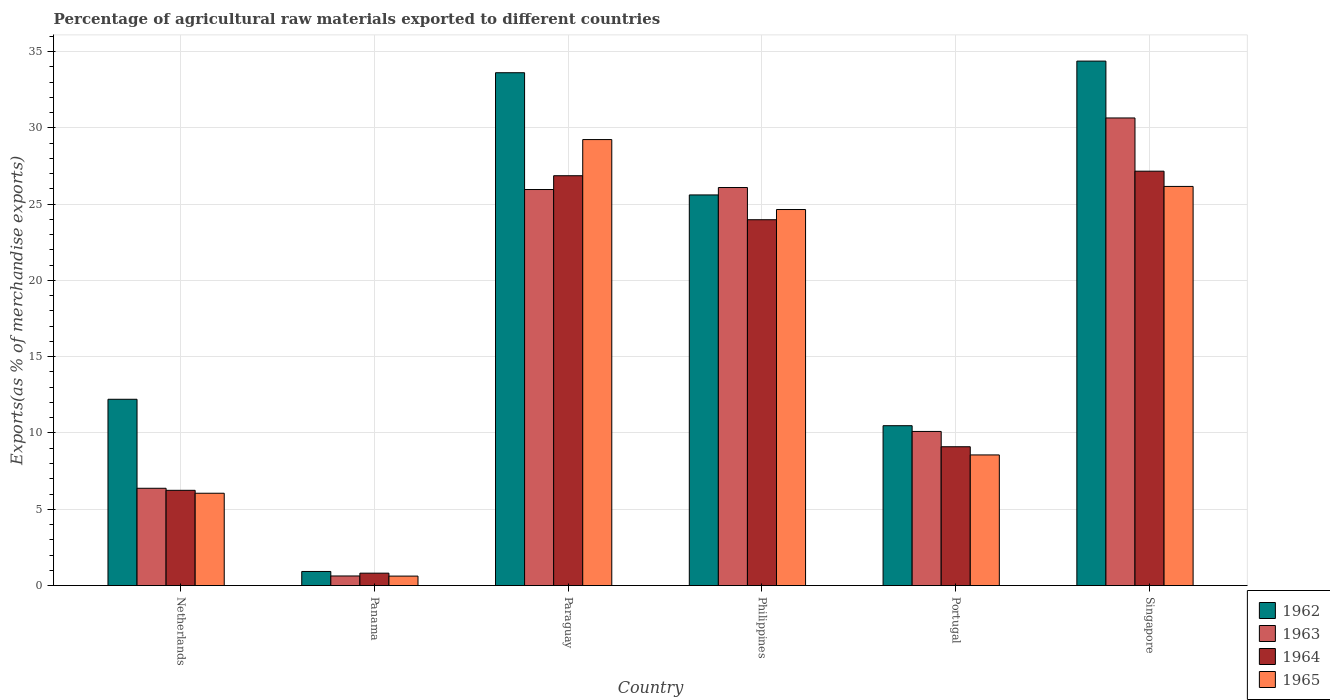How many different coloured bars are there?
Give a very brief answer. 4. How many groups of bars are there?
Your answer should be very brief. 6. How many bars are there on the 3rd tick from the left?
Keep it short and to the point. 4. How many bars are there on the 5th tick from the right?
Ensure brevity in your answer.  4. What is the label of the 3rd group of bars from the left?
Offer a very short reply. Paraguay. In how many cases, is the number of bars for a given country not equal to the number of legend labels?
Provide a short and direct response. 0. What is the percentage of exports to different countries in 1965 in Philippines?
Ensure brevity in your answer.  24.65. Across all countries, what is the maximum percentage of exports to different countries in 1964?
Make the answer very short. 27.16. Across all countries, what is the minimum percentage of exports to different countries in 1964?
Your answer should be compact. 0.81. In which country was the percentage of exports to different countries in 1964 maximum?
Give a very brief answer. Singapore. In which country was the percentage of exports to different countries in 1963 minimum?
Offer a very short reply. Panama. What is the total percentage of exports to different countries in 1964 in the graph?
Your answer should be very brief. 94.16. What is the difference between the percentage of exports to different countries in 1962 in Panama and that in Portugal?
Your response must be concise. -9.55. What is the difference between the percentage of exports to different countries in 1964 in Singapore and the percentage of exports to different countries in 1965 in Portugal?
Make the answer very short. 18.6. What is the average percentage of exports to different countries in 1965 per country?
Ensure brevity in your answer.  15.88. What is the difference between the percentage of exports to different countries of/in 1963 and percentage of exports to different countries of/in 1965 in Panama?
Your response must be concise. 0.01. What is the ratio of the percentage of exports to different countries in 1964 in Paraguay to that in Portugal?
Your answer should be very brief. 2.95. Is the difference between the percentage of exports to different countries in 1963 in Portugal and Singapore greater than the difference between the percentage of exports to different countries in 1965 in Portugal and Singapore?
Your response must be concise. No. What is the difference between the highest and the second highest percentage of exports to different countries in 1963?
Provide a short and direct response. -0.13. What is the difference between the highest and the lowest percentage of exports to different countries in 1963?
Provide a succinct answer. 30.02. What does the 1st bar from the left in Netherlands represents?
Offer a terse response. 1962. What does the 2nd bar from the right in Panama represents?
Your answer should be very brief. 1964. Is it the case that in every country, the sum of the percentage of exports to different countries in 1963 and percentage of exports to different countries in 1964 is greater than the percentage of exports to different countries in 1962?
Your answer should be compact. Yes. How many bars are there?
Provide a short and direct response. 24. How many countries are there in the graph?
Offer a terse response. 6. Are the values on the major ticks of Y-axis written in scientific E-notation?
Ensure brevity in your answer.  No. Where does the legend appear in the graph?
Provide a short and direct response. Bottom right. What is the title of the graph?
Ensure brevity in your answer.  Percentage of agricultural raw materials exported to different countries. Does "1986" appear as one of the legend labels in the graph?
Offer a terse response. No. What is the label or title of the Y-axis?
Offer a very short reply. Exports(as % of merchandise exports). What is the Exports(as % of merchandise exports) in 1962 in Netherlands?
Provide a succinct answer. 12.21. What is the Exports(as % of merchandise exports) of 1963 in Netherlands?
Offer a very short reply. 6.38. What is the Exports(as % of merchandise exports) in 1964 in Netherlands?
Offer a very short reply. 6.24. What is the Exports(as % of merchandise exports) of 1965 in Netherlands?
Your answer should be compact. 6.05. What is the Exports(as % of merchandise exports) of 1962 in Panama?
Provide a short and direct response. 0.92. What is the Exports(as % of merchandise exports) of 1963 in Panama?
Ensure brevity in your answer.  0.63. What is the Exports(as % of merchandise exports) in 1964 in Panama?
Your answer should be compact. 0.81. What is the Exports(as % of merchandise exports) of 1965 in Panama?
Give a very brief answer. 0.62. What is the Exports(as % of merchandise exports) in 1962 in Paraguay?
Your response must be concise. 33.61. What is the Exports(as % of merchandise exports) of 1963 in Paraguay?
Ensure brevity in your answer.  25.96. What is the Exports(as % of merchandise exports) of 1964 in Paraguay?
Your answer should be very brief. 26.86. What is the Exports(as % of merchandise exports) in 1965 in Paraguay?
Give a very brief answer. 29.23. What is the Exports(as % of merchandise exports) in 1962 in Philippines?
Give a very brief answer. 25.6. What is the Exports(as % of merchandise exports) of 1963 in Philippines?
Offer a terse response. 26.09. What is the Exports(as % of merchandise exports) of 1964 in Philippines?
Ensure brevity in your answer.  23.98. What is the Exports(as % of merchandise exports) in 1965 in Philippines?
Your response must be concise. 24.65. What is the Exports(as % of merchandise exports) of 1962 in Portugal?
Your answer should be very brief. 10.48. What is the Exports(as % of merchandise exports) in 1963 in Portugal?
Your response must be concise. 10.1. What is the Exports(as % of merchandise exports) of 1964 in Portugal?
Provide a succinct answer. 9.1. What is the Exports(as % of merchandise exports) of 1965 in Portugal?
Ensure brevity in your answer.  8.56. What is the Exports(as % of merchandise exports) of 1962 in Singapore?
Ensure brevity in your answer.  34.38. What is the Exports(as % of merchandise exports) of 1963 in Singapore?
Keep it short and to the point. 30.65. What is the Exports(as % of merchandise exports) in 1964 in Singapore?
Keep it short and to the point. 27.16. What is the Exports(as % of merchandise exports) in 1965 in Singapore?
Make the answer very short. 26.16. Across all countries, what is the maximum Exports(as % of merchandise exports) of 1962?
Make the answer very short. 34.38. Across all countries, what is the maximum Exports(as % of merchandise exports) in 1963?
Your answer should be compact. 30.65. Across all countries, what is the maximum Exports(as % of merchandise exports) of 1964?
Make the answer very short. 27.16. Across all countries, what is the maximum Exports(as % of merchandise exports) of 1965?
Keep it short and to the point. 29.23. Across all countries, what is the minimum Exports(as % of merchandise exports) in 1962?
Keep it short and to the point. 0.92. Across all countries, what is the minimum Exports(as % of merchandise exports) in 1963?
Give a very brief answer. 0.63. Across all countries, what is the minimum Exports(as % of merchandise exports) of 1964?
Your response must be concise. 0.81. Across all countries, what is the minimum Exports(as % of merchandise exports) in 1965?
Your answer should be compact. 0.62. What is the total Exports(as % of merchandise exports) of 1962 in the graph?
Provide a succinct answer. 117.21. What is the total Exports(as % of merchandise exports) in 1963 in the graph?
Your answer should be very brief. 99.8. What is the total Exports(as % of merchandise exports) in 1964 in the graph?
Give a very brief answer. 94.16. What is the total Exports(as % of merchandise exports) of 1965 in the graph?
Your response must be concise. 95.28. What is the difference between the Exports(as % of merchandise exports) of 1962 in Netherlands and that in Panama?
Ensure brevity in your answer.  11.29. What is the difference between the Exports(as % of merchandise exports) in 1963 in Netherlands and that in Panama?
Give a very brief answer. 5.75. What is the difference between the Exports(as % of merchandise exports) in 1964 in Netherlands and that in Panama?
Your answer should be very brief. 5.43. What is the difference between the Exports(as % of merchandise exports) in 1965 in Netherlands and that in Panama?
Give a very brief answer. 5.43. What is the difference between the Exports(as % of merchandise exports) of 1962 in Netherlands and that in Paraguay?
Your answer should be compact. -21.4. What is the difference between the Exports(as % of merchandise exports) of 1963 in Netherlands and that in Paraguay?
Make the answer very short. -19.58. What is the difference between the Exports(as % of merchandise exports) of 1964 in Netherlands and that in Paraguay?
Provide a succinct answer. -20.62. What is the difference between the Exports(as % of merchandise exports) in 1965 in Netherlands and that in Paraguay?
Your answer should be compact. -23.18. What is the difference between the Exports(as % of merchandise exports) of 1962 in Netherlands and that in Philippines?
Offer a terse response. -13.39. What is the difference between the Exports(as % of merchandise exports) in 1963 in Netherlands and that in Philippines?
Your answer should be very brief. -19.71. What is the difference between the Exports(as % of merchandise exports) of 1964 in Netherlands and that in Philippines?
Keep it short and to the point. -17.74. What is the difference between the Exports(as % of merchandise exports) in 1965 in Netherlands and that in Philippines?
Ensure brevity in your answer.  -18.6. What is the difference between the Exports(as % of merchandise exports) in 1962 in Netherlands and that in Portugal?
Keep it short and to the point. 1.73. What is the difference between the Exports(as % of merchandise exports) of 1963 in Netherlands and that in Portugal?
Give a very brief answer. -3.73. What is the difference between the Exports(as % of merchandise exports) of 1964 in Netherlands and that in Portugal?
Provide a short and direct response. -2.86. What is the difference between the Exports(as % of merchandise exports) in 1965 in Netherlands and that in Portugal?
Your answer should be compact. -2.51. What is the difference between the Exports(as % of merchandise exports) in 1962 in Netherlands and that in Singapore?
Make the answer very short. -22.17. What is the difference between the Exports(as % of merchandise exports) of 1963 in Netherlands and that in Singapore?
Provide a short and direct response. -24.27. What is the difference between the Exports(as % of merchandise exports) of 1964 in Netherlands and that in Singapore?
Your answer should be compact. -20.92. What is the difference between the Exports(as % of merchandise exports) of 1965 in Netherlands and that in Singapore?
Make the answer very short. -20.11. What is the difference between the Exports(as % of merchandise exports) of 1962 in Panama and that in Paraguay?
Your answer should be compact. -32.69. What is the difference between the Exports(as % of merchandise exports) of 1963 in Panama and that in Paraguay?
Your answer should be very brief. -25.33. What is the difference between the Exports(as % of merchandise exports) in 1964 in Panama and that in Paraguay?
Make the answer very short. -26.05. What is the difference between the Exports(as % of merchandise exports) of 1965 in Panama and that in Paraguay?
Ensure brevity in your answer.  -28.61. What is the difference between the Exports(as % of merchandise exports) in 1962 in Panama and that in Philippines?
Your answer should be very brief. -24.68. What is the difference between the Exports(as % of merchandise exports) in 1963 in Panama and that in Philippines?
Offer a terse response. -25.46. What is the difference between the Exports(as % of merchandise exports) of 1964 in Panama and that in Philippines?
Ensure brevity in your answer.  -23.17. What is the difference between the Exports(as % of merchandise exports) of 1965 in Panama and that in Philippines?
Keep it short and to the point. -24.03. What is the difference between the Exports(as % of merchandise exports) of 1962 in Panama and that in Portugal?
Provide a succinct answer. -9.55. What is the difference between the Exports(as % of merchandise exports) in 1963 in Panama and that in Portugal?
Your answer should be very brief. -9.47. What is the difference between the Exports(as % of merchandise exports) of 1964 in Panama and that in Portugal?
Keep it short and to the point. -8.29. What is the difference between the Exports(as % of merchandise exports) in 1965 in Panama and that in Portugal?
Your answer should be compact. -7.94. What is the difference between the Exports(as % of merchandise exports) of 1962 in Panama and that in Singapore?
Offer a very short reply. -33.45. What is the difference between the Exports(as % of merchandise exports) of 1963 in Panama and that in Singapore?
Give a very brief answer. -30.02. What is the difference between the Exports(as % of merchandise exports) of 1964 in Panama and that in Singapore?
Provide a short and direct response. -26.35. What is the difference between the Exports(as % of merchandise exports) in 1965 in Panama and that in Singapore?
Keep it short and to the point. -25.54. What is the difference between the Exports(as % of merchandise exports) of 1962 in Paraguay and that in Philippines?
Keep it short and to the point. 8.01. What is the difference between the Exports(as % of merchandise exports) in 1963 in Paraguay and that in Philippines?
Keep it short and to the point. -0.13. What is the difference between the Exports(as % of merchandise exports) of 1964 in Paraguay and that in Philippines?
Your answer should be very brief. 2.88. What is the difference between the Exports(as % of merchandise exports) of 1965 in Paraguay and that in Philippines?
Provide a succinct answer. 4.59. What is the difference between the Exports(as % of merchandise exports) of 1962 in Paraguay and that in Portugal?
Your answer should be very brief. 23.14. What is the difference between the Exports(as % of merchandise exports) of 1963 in Paraguay and that in Portugal?
Give a very brief answer. 15.86. What is the difference between the Exports(as % of merchandise exports) in 1964 in Paraguay and that in Portugal?
Ensure brevity in your answer.  17.76. What is the difference between the Exports(as % of merchandise exports) of 1965 in Paraguay and that in Portugal?
Offer a very short reply. 20.67. What is the difference between the Exports(as % of merchandise exports) of 1962 in Paraguay and that in Singapore?
Your response must be concise. -0.76. What is the difference between the Exports(as % of merchandise exports) of 1963 in Paraguay and that in Singapore?
Your answer should be very brief. -4.69. What is the difference between the Exports(as % of merchandise exports) in 1964 in Paraguay and that in Singapore?
Your answer should be compact. -0.3. What is the difference between the Exports(as % of merchandise exports) of 1965 in Paraguay and that in Singapore?
Make the answer very short. 3.07. What is the difference between the Exports(as % of merchandise exports) of 1962 in Philippines and that in Portugal?
Your response must be concise. 15.13. What is the difference between the Exports(as % of merchandise exports) of 1963 in Philippines and that in Portugal?
Offer a terse response. 15.99. What is the difference between the Exports(as % of merchandise exports) of 1964 in Philippines and that in Portugal?
Offer a very short reply. 14.88. What is the difference between the Exports(as % of merchandise exports) in 1965 in Philippines and that in Portugal?
Offer a terse response. 16.08. What is the difference between the Exports(as % of merchandise exports) in 1962 in Philippines and that in Singapore?
Your response must be concise. -8.77. What is the difference between the Exports(as % of merchandise exports) in 1963 in Philippines and that in Singapore?
Ensure brevity in your answer.  -4.56. What is the difference between the Exports(as % of merchandise exports) in 1964 in Philippines and that in Singapore?
Your answer should be very brief. -3.18. What is the difference between the Exports(as % of merchandise exports) in 1965 in Philippines and that in Singapore?
Provide a short and direct response. -1.51. What is the difference between the Exports(as % of merchandise exports) of 1962 in Portugal and that in Singapore?
Offer a terse response. -23.9. What is the difference between the Exports(as % of merchandise exports) of 1963 in Portugal and that in Singapore?
Offer a very short reply. -20.55. What is the difference between the Exports(as % of merchandise exports) of 1964 in Portugal and that in Singapore?
Your answer should be very brief. -18.06. What is the difference between the Exports(as % of merchandise exports) of 1965 in Portugal and that in Singapore?
Give a very brief answer. -17.6. What is the difference between the Exports(as % of merchandise exports) of 1962 in Netherlands and the Exports(as % of merchandise exports) of 1963 in Panama?
Give a very brief answer. 11.58. What is the difference between the Exports(as % of merchandise exports) in 1962 in Netherlands and the Exports(as % of merchandise exports) in 1964 in Panama?
Give a very brief answer. 11.4. What is the difference between the Exports(as % of merchandise exports) in 1962 in Netherlands and the Exports(as % of merchandise exports) in 1965 in Panama?
Give a very brief answer. 11.59. What is the difference between the Exports(as % of merchandise exports) in 1963 in Netherlands and the Exports(as % of merchandise exports) in 1964 in Panama?
Offer a very short reply. 5.56. What is the difference between the Exports(as % of merchandise exports) in 1963 in Netherlands and the Exports(as % of merchandise exports) in 1965 in Panama?
Keep it short and to the point. 5.76. What is the difference between the Exports(as % of merchandise exports) in 1964 in Netherlands and the Exports(as % of merchandise exports) in 1965 in Panama?
Give a very brief answer. 5.62. What is the difference between the Exports(as % of merchandise exports) of 1962 in Netherlands and the Exports(as % of merchandise exports) of 1963 in Paraguay?
Your answer should be compact. -13.75. What is the difference between the Exports(as % of merchandise exports) of 1962 in Netherlands and the Exports(as % of merchandise exports) of 1964 in Paraguay?
Your answer should be very brief. -14.65. What is the difference between the Exports(as % of merchandise exports) of 1962 in Netherlands and the Exports(as % of merchandise exports) of 1965 in Paraguay?
Your response must be concise. -17.02. What is the difference between the Exports(as % of merchandise exports) of 1963 in Netherlands and the Exports(as % of merchandise exports) of 1964 in Paraguay?
Your response must be concise. -20.49. What is the difference between the Exports(as % of merchandise exports) of 1963 in Netherlands and the Exports(as % of merchandise exports) of 1965 in Paraguay?
Offer a very short reply. -22.86. What is the difference between the Exports(as % of merchandise exports) of 1964 in Netherlands and the Exports(as % of merchandise exports) of 1965 in Paraguay?
Make the answer very short. -22.99. What is the difference between the Exports(as % of merchandise exports) of 1962 in Netherlands and the Exports(as % of merchandise exports) of 1963 in Philippines?
Make the answer very short. -13.88. What is the difference between the Exports(as % of merchandise exports) in 1962 in Netherlands and the Exports(as % of merchandise exports) in 1964 in Philippines?
Give a very brief answer. -11.77. What is the difference between the Exports(as % of merchandise exports) in 1962 in Netherlands and the Exports(as % of merchandise exports) in 1965 in Philippines?
Give a very brief answer. -12.44. What is the difference between the Exports(as % of merchandise exports) of 1963 in Netherlands and the Exports(as % of merchandise exports) of 1964 in Philippines?
Keep it short and to the point. -17.6. What is the difference between the Exports(as % of merchandise exports) in 1963 in Netherlands and the Exports(as % of merchandise exports) in 1965 in Philippines?
Your answer should be very brief. -18.27. What is the difference between the Exports(as % of merchandise exports) of 1964 in Netherlands and the Exports(as % of merchandise exports) of 1965 in Philippines?
Ensure brevity in your answer.  -18.4. What is the difference between the Exports(as % of merchandise exports) in 1962 in Netherlands and the Exports(as % of merchandise exports) in 1963 in Portugal?
Give a very brief answer. 2.11. What is the difference between the Exports(as % of merchandise exports) in 1962 in Netherlands and the Exports(as % of merchandise exports) in 1964 in Portugal?
Your answer should be very brief. 3.11. What is the difference between the Exports(as % of merchandise exports) in 1962 in Netherlands and the Exports(as % of merchandise exports) in 1965 in Portugal?
Ensure brevity in your answer.  3.65. What is the difference between the Exports(as % of merchandise exports) in 1963 in Netherlands and the Exports(as % of merchandise exports) in 1964 in Portugal?
Make the answer very short. -2.72. What is the difference between the Exports(as % of merchandise exports) of 1963 in Netherlands and the Exports(as % of merchandise exports) of 1965 in Portugal?
Your answer should be very brief. -2.19. What is the difference between the Exports(as % of merchandise exports) in 1964 in Netherlands and the Exports(as % of merchandise exports) in 1965 in Portugal?
Give a very brief answer. -2.32. What is the difference between the Exports(as % of merchandise exports) of 1962 in Netherlands and the Exports(as % of merchandise exports) of 1963 in Singapore?
Keep it short and to the point. -18.44. What is the difference between the Exports(as % of merchandise exports) of 1962 in Netherlands and the Exports(as % of merchandise exports) of 1964 in Singapore?
Provide a short and direct response. -14.95. What is the difference between the Exports(as % of merchandise exports) of 1962 in Netherlands and the Exports(as % of merchandise exports) of 1965 in Singapore?
Provide a succinct answer. -13.95. What is the difference between the Exports(as % of merchandise exports) in 1963 in Netherlands and the Exports(as % of merchandise exports) in 1964 in Singapore?
Offer a terse response. -20.78. What is the difference between the Exports(as % of merchandise exports) in 1963 in Netherlands and the Exports(as % of merchandise exports) in 1965 in Singapore?
Ensure brevity in your answer.  -19.78. What is the difference between the Exports(as % of merchandise exports) of 1964 in Netherlands and the Exports(as % of merchandise exports) of 1965 in Singapore?
Your answer should be very brief. -19.92. What is the difference between the Exports(as % of merchandise exports) in 1962 in Panama and the Exports(as % of merchandise exports) in 1963 in Paraguay?
Provide a succinct answer. -25.03. What is the difference between the Exports(as % of merchandise exports) in 1962 in Panama and the Exports(as % of merchandise exports) in 1964 in Paraguay?
Make the answer very short. -25.94. What is the difference between the Exports(as % of merchandise exports) of 1962 in Panama and the Exports(as % of merchandise exports) of 1965 in Paraguay?
Your answer should be compact. -28.31. What is the difference between the Exports(as % of merchandise exports) in 1963 in Panama and the Exports(as % of merchandise exports) in 1964 in Paraguay?
Your answer should be compact. -26.23. What is the difference between the Exports(as % of merchandise exports) of 1963 in Panama and the Exports(as % of merchandise exports) of 1965 in Paraguay?
Ensure brevity in your answer.  -28.6. What is the difference between the Exports(as % of merchandise exports) of 1964 in Panama and the Exports(as % of merchandise exports) of 1965 in Paraguay?
Offer a very short reply. -28.42. What is the difference between the Exports(as % of merchandise exports) of 1962 in Panama and the Exports(as % of merchandise exports) of 1963 in Philippines?
Keep it short and to the point. -25.16. What is the difference between the Exports(as % of merchandise exports) in 1962 in Panama and the Exports(as % of merchandise exports) in 1964 in Philippines?
Offer a very short reply. -23.05. What is the difference between the Exports(as % of merchandise exports) of 1962 in Panama and the Exports(as % of merchandise exports) of 1965 in Philippines?
Ensure brevity in your answer.  -23.72. What is the difference between the Exports(as % of merchandise exports) of 1963 in Panama and the Exports(as % of merchandise exports) of 1964 in Philippines?
Keep it short and to the point. -23.35. What is the difference between the Exports(as % of merchandise exports) in 1963 in Panama and the Exports(as % of merchandise exports) in 1965 in Philippines?
Provide a short and direct response. -24.02. What is the difference between the Exports(as % of merchandise exports) in 1964 in Panama and the Exports(as % of merchandise exports) in 1965 in Philippines?
Offer a very short reply. -23.84. What is the difference between the Exports(as % of merchandise exports) of 1962 in Panama and the Exports(as % of merchandise exports) of 1963 in Portugal?
Make the answer very short. -9.18. What is the difference between the Exports(as % of merchandise exports) in 1962 in Panama and the Exports(as % of merchandise exports) in 1964 in Portugal?
Provide a succinct answer. -8.17. What is the difference between the Exports(as % of merchandise exports) of 1962 in Panama and the Exports(as % of merchandise exports) of 1965 in Portugal?
Your response must be concise. -7.64. What is the difference between the Exports(as % of merchandise exports) of 1963 in Panama and the Exports(as % of merchandise exports) of 1964 in Portugal?
Your response must be concise. -8.47. What is the difference between the Exports(as % of merchandise exports) of 1963 in Panama and the Exports(as % of merchandise exports) of 1965 in Portugal?
Offer a terse response. -7.93. What is the difference between the Exports(as % of merchandise exports) of 1964 in Panama and the Exports(as % of merchandise exports) of 1965 in Portugal?
Offer a terse response. -7.75. What is the difference between the Exports(as % of merchandise exports) in 1962 in Panama and the Exports(as % of merchandise exports) in 1963 in Singapore?
Provide a succinct answer. -29.72. What is the difference between the Exports(as % of merchandise exports) of 1962 in Panama and the Exports(as % of merchandise exports) of 1964 in Singapore?
Give a very brief answer. -26.24. What is the difference between the Exports(as % of merchandise exports) of 1962 in Panama and the Exports(as % of merchandise exports) of 1965 in Singapore?
Offer a terse response. -25.24. What is the difference between the Exports(as % of merchandise exports) of 1963 in Panama and the Exports(as % of merchandise exports) of 1964 in Singapore?
Give a very brief answer. -26.53. What is the difference between the Exports(as % of merchandise exports) in 1963 in Panama and the Exports(as % of merchandise exports) in 1965 in Singapore?
Offer a very short reply. -25.53. What is the difference between the Exports(as % of merchandise exports) of 1964 in Panama and the Exports(as % of merchandise exports) of 1965 in Singapore?
Your response must be concise. -25.35. What is the difference between the Exports(as % of merchandise exports) in 1962 in Paraguay and the Exports(as % of merchandise exports) in 1963 in Philippines?
Your answer should be very brief. 7.53. What is the difference between the Exports(as % of merchandise exports) of 1962 in Paraguay and the Exports(as % of merchandise exports) of 1964 in Philippines?
Provide a succinct answer. 9.64. What is the difference between the Exports(as % of merchandise exports) of 1962 in Paraguay and the Exports(as % of merchandise exports) of 1965 in Philippines?
Offer a very short reply. 8.97. What is the difference between the Exports(as % of merchandise exports) in 1963 in Paraguay and the Exports(as % of merchandise exports) in 1964 in Philippines?
Offer a terse response. 1.98. What is the difference between the Exports(as % of merchandise exports) of 1963 in Paraguay and the Exports(as % of merchandise exports) of 1965 in Philippines?
Offer a very short reply. 1.31. What is the difference between the Exports(as % of merchandise exports) of 1964 in Paraguay and the Exports(as % of merchandise exports) of 1965 in Philippines?
Ensure brevity in your answer.  2.22. What is the difference between the Exports(as % of merchandise exports) in 1962 in Paraguay and the Exports(as % of merchandise exports) in 1963 in Portugal?
Offer a terse response. 23.51. What is the difference between the Exports(as % of merchandise exports) in 1962 in Paraguay and the Exports(as % of merchandise exports) in 1964 in Portugal?
Provide a succinct answer. 24.52. What is the difference between the Exports(as % of merchandise exports) in 1962 in Paraguay and the Exports(as % of merchandise exports) in 1965 in Portugal?
Offer a terse response. 25.05. What is the difference between the Exports(as % of merchandise exports) of 1963 in Paraguay and the Exports(as % of merchandise exports) of 1964 in Portugal?
Your answer should be compact. 16.86. What is the difference between the Exports(as % of merchandise exports) in 1963 in Paraguay and the Exports(as % of merchandise exports) in 1965 in Portugal?
Offer a terse response. 17.4. What is the difference between the Exports(as % of merchandise exports) in 1964 in Paraguay and the Exports(as % of merchandise exports) in 1965 in Portugal?
Offer a very short reply. 18.3. What is the difference between the Exports(as % of merchandise exports) in 1962 in Paraguay and the Exports(as % of merchandise exports) in 1963 in Singapore?
Provide a succinct answer. 2.97. What is the difference between the Exports(as % of merchandise exports) of 1962 in Paraguay and the Exports(as % of merchandise exports) of 1964 in Singapore?
Keep it short and to the point. 6.45. What is the difference between the Exports(as % of merchandise exports) in 1962 in Paraguay and the Exports(as % of merchandise exports) in 1965 in Singapore?
Provide a short and direct response. 7.45. What is the difference between the Exports(as % of merchandise exports) of 1963 in Paraguay and the Exports(as % of merchandise exports) of 1964 in Singapore?
Make the answer very short. -1.2. What is the difference between the Exports(as % of merchandise exports) in 1963 in Paraguay and the Exports(as % of merchandise exports) in 1965 in Singapore?
Keep it short and to the point. -0.2. What is the difference between the Exports(as % of merchandise exports) of 1964 in Paraguay and the Exports(as % of merchandise exports) of 1965 in Singapore?
Provide a short and direct response. 0.7. What is the difference between the Exports(as % of merchandise exports) in 1962 in Philippines and the Exports(as % of merchandise exports) in 1963 in Portugal?
Your response must be concise. 15.5. What is the difference between the Exports(as % of merchandise exports) of 1962 in Philippines and the Exports(as % of merchandise exports) of 1964 in Portugal?
Make the answer very short. 16.5. What is the difference between the Exports(as % of merchandise exports) of 1962 in Philippines and the Exports(as % of merchandise exports) of 1965 in Portugal?
Ensure brevity in your answer.  17.04. What is the difference between the Exports(as % of merchandise exports) in 1963 in Philippines and the Exports(as % of merchandise exports) in 1964 in Portugal?
Provide a succinct answer. 16.99. What is the difference between the Exports(as % of merchandise exports) of 1963 in Philippines and the Exports(as % of merchandise exports) of 1965 in Portugal?
Offer a very short reply. 17.53. What is the difference between the Exports(as % of merchandise exports) in 1964 in Philippines and the Exports(as % of merchandise exports) in 1965 in Portugal?
Your answer should be compact. 15.42. What is the difference between the Exports(as % of merchandise exports) of 1962 in Philippines and the Exports(as % of merchandise exports) of 1963 in Singapore?
Offer a very short reply. -5.04. What is the difference between the Exports(as % of merchandise exports) of 1962 in Philippines and the Exports(as % of merchandise exports) of 1964 in Singapore?
Your answer should be compact. -1.56. What is the difference between the Exports(as % of merchandise exports) of 1962 in Philippines and the Exports(as % of merchandise exports) of 1965 in Singapore?
Your response must be concise. -0.56. What is the difference between the Exports(as % of merchandise exports) in 1963 in Philippines and the Exports(as % of merchandise exports) in 1964 in Singapore?
Give a very brief answer. -1.07. What is the difference between the Exports(as % of merchandise exports) of 1963 in Philippines and the Exports(as % of merchandise exports) of 1965 in Singapore?
Ensure brevity in your answer.  -0.07. What is the difference between the Exports(as % of merchandise exports) in 1964 in Philippines and the Exports(as % of merchandise exports) in 1965 in Singapore?
Your answer should be very brief. -2.18. What is the difference between the Exports(as % of merchandise exports) of 1962 in Portugal and the Exports(as % of merchandise exports) of 1963 in Singapore?
Offer a terse response. -20.17. What is the difference between the Exports(as % of merchandise exports) in 1962 in Portugal and the Exports(as % of merchandise exports) in 1964 in Singapore?
Keep it short and to the point. -16.68. What is the difference between the Exports(as % of merchandise exports) in 1962 in Portugal and the Exports(as % of merchandise exports) in 1965 in Singapore?
Keep it short and to the point. -15.68. What is the difference between the Exports(as % of merchandise exports) of 1963 in Portugal and the Exports(as % of merchandise exports) of 1964 in Singapore?
Offer a very short reply. -17.06. What is the difference between the Exports(as % of merchandise exports) in 1963 in Portugal and the Exports(as % of merchandise exports) in 1965 in Singapore?
Offer a terse response. -16.06. What is the difference between the Exports(as % of merchandise exports) of 1964 in Portugal and the Exports(as % of merchandise exports) of 1965 in Singapore?
Offer a terse response. -17.06. What is the average Exports(as % of merchandise exports) of 1962 per country?
Provide a succinct answer. 19.53. What is the average Exports(as % of merchandise exports) in 1963 per country?
Provide a succinct answer. 16.63. What is the average Exports(as % of merchandise exports) of 1964 per country?
Offer a terse response. 15.69. What is the average Exports(as % of merchandise exports) of 1965 per country?
Your answer should be very brief. 15.88. What is the difference between the Exports(as % of merchandise exports) in 1962 and Exports(as % of merchandise exports) in 1963 in Netherlands?
Offer a very short reply. 5.83. What is the difference between the Exports(as % of merchandise exports) in 1962 and Exports(as % of merchandise exports) in 1964 in Netherlands?
Your response must be concise. 5.97. What is the difference between the Exports(as % of merchandise exports) in 1962 and Exports(as % of merchandise exports) in 1965 in Netherlands?
Provide a succinct answer. 6.16. What is the difference between the Exports(as % of merchandise exports) in 1963 and Exports(as % of merchandise exports) in 1964 in Netherlands?
Offer a very short reply. 0.13. What is the difference between the Exports(as % of merchandise exports) of 1963 and Exports(as % of merchandise exports) of 1965 in Netherlands?
Your answer should be compact. 0.32. What is the difference between the Exports(as % of merchandise exports) of 1964 and Exports(as % of merchandise exports) of 1965 in Netherlands?
Offer a terse response. 0.19. What is the difference between the Exports(as % of merchandise exports) in 1962 and Exports(as % of merchandise exports) in 1963 in Panama?
Keep it short and to the point. 0.3. What is the difference between the Exports(as % of merchandise exports) in 1962 and Exports(as % of merchandise exports) in 1964 in Panama?
Make the answer very short. 0.11. What is the difference between the Exports(as % of merchandise exports) in 1962 and Exports(as % of merchandise exports) in 1965 in Panama?
Provide a succinct answer. 0.3. What is the difference between the Exports(as % of merchandise exports) in 1963 and Exports(as % of merchandise exports) in 1964 in Panama?
Offer a very short reply. -0.18. What is the difference between the Exports(as % of merchandise exports) of 1963 and Exports(as % of merchandise exports) of 1965 in Panama?
Your answer should be very brief. 0.01. What is the difference between the Exports(as % of merchandise exports) in 1964 and Exports(as % of merchandise exports) in 1965 in Panama?
Your answer should be very brief. 0.19. What is the difference between the Exports(as % of merchandise exports) in 1962 and Exports(as % of merchandise exports) in 1963 in Paraguay?
Give a very brief answer. 7.66. What is the difference between the Exports(as % of merchandise exports) of 1962 and Exports(as % of merchandise exports) of 1964 in Paraguay?
Make the answer very short. 6.75. What is the difference between the Exports(as % of merchandise exports) in 1962 and Exports(as % of merchandise exports) in 1965 in Paraguay?
Offer a very short reply. 4.38. What is the difference between the Exports(as % of merchandise exports) of 1963 and Exports(as % of merchandise exports) of 1964 in Paraguay?
Your answer should be compact. -0.9. What is the difference between the Exports(as % of merchandise exports) of 1963 and Exports(as % of merchandise exports) of 1965 in Paraguay?
Your response must be concise. -3.27. What is the difference between the Exports(as % of merchandise exports) in 1964 and Exports(as % of merchandise exports) in 1965 in Paraguay?
Your answer should be very brief. -2.37. What is the difference between the Exports(as % of merchandise exports) of 1962 and Exports(as % of merchandise exports) of 1963 in Philippines?
Ensure brevity in your answer.  -0.49. What is the difference between the Exports(as % of merchandise exports) of 1962 and Exports(as % of merchandise exports) of 1964 in Philippines?
Offer a terse response. 1.63. What is the difference between the Exports(as % of merchandise exports) in 1962 and Exports(as % of merchandise exports) in 1965 in Philippines?
Provide a short and direct response. 0.96. What is the difference between the Exports(as % of merchandise exports) of 1963 and Exports(as % of merchandise exports) of 1964 in Philippines?
Keep it short and to the point. 2.11. What is the difference between the Exports(as % of merchandise exports) of 1963 and Exports(as % of merchandise exports) of 1965 in Philippines?
Offer a terse response. 1.44. What is the difference between the Exports(as % of merchandise exports) in 1964 and Exports(as % of merchandise exports) in 1965 in Philippines?
Offer a terse response. -0.67. What is the difference between the Exports(as % of merchandise exports) of 1962 and Exports(as % of merchandise exports) of 1963 in Portugal?
Provide a succinct answer. 0.38. What is the difference between the Exports(as % of merchandise exports) of 1962 and Exports(as % of merchandise exports) of 1964 in Portugal?
Offer a very short reply. 1.38. What is the difference between the Exports(as % of merchandise exports) of 1962 and Exports(as % of merchandise exports) of 1965 in Portugal?
Your response must be concise. 1.92. What is the difference between the Exports(as % of merchandise exports) in 1963 and Exports(as % of merchandise exports) in 1964 in Portugal?
Make the answer very short. 1. What is the difference between the Exports(as % of merchandise exports) in 1963 and Exports(as % of merchandise exports) in 1965 in Portugal?
Your answer should be very brief. 1.54. What is the difference between the Exports(as % of merchandise exports) in 1964 and Exports(as % of merchandise exports) in 1965 in Portugal?
Give a very brief answer. 0.54. What is the difference between the Exports(as % of merchandise exports) of 1962 and Exports(as % of merchandise exports) of 1963 in Singapore?
Your answer should be very brief. 3.73. What is the difference between the Exports(as % of merchandise exports) in 1962 and Exports(as % of merchandise exports) in 1964 in Singapore?
Your response must be concise. 7.22. What is the difference between the Exports(as % of merchandise exports) in 1962 and Exports(as % of merchandise exports) in 1965 in Singapore?
Your answer should be very brief. 8.22. What is the difference between the Exports(as % of merchandise exports) in 1963 and Exports(as % of merchandise exports) in 1964 in Singapore?
Your answer should be very brief. 3.49. What is the difference between the Exports(as % of merchandise exports) of 1963 and Exports(as % of merchandise exports) of 1965 in Singapore?
Provide a succinct answer. 4.49. What is the ratio of the Exports(as % of merchandise exports) of 1962 in Netherlands to that in Panama?
Give a very brief answer. 13.21. What is the ratio of the Exports(as % of merchandise exports) in 1963 in Netherlands to that in Panama?
Provide a succinct answer. 10.15. What is the ratio of the Exports(as % of merchandise exports) of 1964 in Netherlands to that in Panama?
Ensure brevity in your answer.  7.69. What is the ratio of the Exports(as % of merchandise exports) in 1965 in Netherlands to that in Panama?
Provide a short and direct response. 9.75. What is the ratio of the Exports(as % of merchandise exports) of 1962 in Netherlands to that in Paraguay?
Offer a terse response. 0.36. What is the ratio of the Exports(as % of merchandise exports) of 1963 in Netherlands to that in Paraguay?
Your response must be concise. 0.25. What is the ratio of the Exports(as % of merchandise exports) in 1964 in Netherlands to that in Paraguay?
Offer a terse response. 0.23. What is the ratio of the Exports(as % of merchandise exports) in 1965 in Netherlands to that in Paraguay?
Make the answer very short. 0.21. What is the ratio of the Exports(as % of merchandise exports) of 1962 in Netherlands to that in Philippines?
Make the answer very short. 0.48. What is the ratio of the Exports(as % of merchandise exports) of 1963 in Netherlands to that in Philippines?
Your response must be concise. 0.24. What is the ratio of the Exports(as % of merchandise exports) in 1964 in Netherlands to that in Philippines?
Your answer should be very brief. 0.26. What is the ratio of the Exports(as % of merchandise exports) in 1965 in Netherlands to that in Philippines?
Offer a terse response. 0.25. What is the ratio of the Exports(as % of merchandise exports) in 1962 in Netherlands to that in Portugal?
Your response must be concise. 1.17. What is the ratio of the Exports(as % of merchandise exports) of 1963 in Netherlands to that in Portugal?
Offer a very short reply. 0.63. What is the ratio of the Exports(as % of merchandise exports) in 1964 in Netherlands to that in Portugal?
Offer a terse response. 0.69. What is the ratio of the Exports(as % of merchandise exports) in 1965 in Netherlands to that in Portugal?
Offer a very short reply. 0.71. What is the ratio of the Exports(as % of merchandise exports) in 1962 in Netherlands to that in Singapore?
Your answer should be compact. 0.36. What is the ratio of the Exports(as % of merchandise exports) of 1963 in Netherlands to that in Singapore?
Your answer should be very brief. 0.21. What is the ratio of the Exports(as % of merchandise exports) of 1964 in Netherlands to that in Singapore?
Make the answer very short. 0.23. What is the ratio of the Exports(as % of merchandise exports) of 1965 in Netherlands to that in Singapore?
Offer a very short reply. 0.23. What is the ratio of the Exports(as % of merchandise exports) in 1962 in Panama to that in Paraguay?
Ensure brevity in your answer.  0.03. What is the ratio of the Exports(as % of merchandise exports) in 1963 in Panama to that in Paraguay?
Provide a succinct answer. 0.02. What is the ratio of the Exports(as % of merchandise exports) of 1964 in Panama to that in Paraguay?
Your response must be concise. 0.03. What is the ratio of the Exports(as % of merchandise exports) of 1965 in Panama to that in Paraguay?
Ensure brevity in your answer.  0.02. What is the ratio of the Exports(as % of merchandise exports) in 1962 in Panama to that in Philippines?
Give a very brief answer. 0.04. What is the ratio of the Exports(as % of merchandise exports) of 1963 in Panama to that in Philippines?
Provide a succinct answer. 0.02. What is the ratio of the Exports(as % of merchandise exports) in 1964 in Panama to that in Philippines?
Offer a terse response. 0.03. What is the ratio of the Exports(as % of merchandise exports) in 1965 in Panama to that in Philippines?
Give a very brief answer. 0.03. What is the ratio of the Exports(as % of merchandise exports) of 1962 in Panama to that in Portugal?
Provide a succinct answer. 0.09. What is the ratio of the Exports(as % of merchandise exports) in 1963 in Panama to that in Portugal?
Your answer should be compact. 0.06. What is the ratio of the Exports(as % of merchandise exports) of 1964 in Panama to that in Portugal?
Offer a very short reply. 0.09. What is the ratio of the Exports(as % of merchandise exports) in 1965 in Panama to that in Portugal?
Offer a very short reply. 0.07. What is the ratio of the Exports(as % of merchandise exports) of 1962 in Panama to that in Singapore?
Give a very brief answer. 0.03. What is the ratio of the Exports(as % of merchandise exports) in 1963 in Panama to that in Singapore?
Offer a very short reply. 0.02. What is the ratio of the Exports(as % of merchandise exports) of 1964 in Panama to that in Singapore?
Offer a terse response. 0.03. What is the ratio of the Exports(as % of merchandise exports) in 1965 in Panama to that in Singapore?
Offer a very short reply. 0.02. What is the ratio of the Exports(as % of merchandise exports) of 1962 in Paraguay to that in Philippines?
Provide a short and direct response. 1.31. What is the ratio of the Exports(as % of merchandise exports) of 1964 in Paraguay to that in Philippines?
Provide a succinct answer. 1.12. What is the ratio of the Exports(as % of merchandise exports) in 1965 in Paraguay to that in Philippines?
Your answer should be compact. 1.19. What is the ratio of the Exports(as % of merchandise exports) of 1962 in Paraguay to that in Portugal?
Offer a terse response. 3.21. What is the ratio of the Exports(as % of merchandise exports) of 1963 in Paraguay to that in Portugal?
Your response must be concise. 2.57. What is the ratio of the Exports(as % of merchandise exports) of 1964 in Paraguay to that in Portugal?
Your answer should be very brief. 2.95. What is the ratio of the Exports(as % of merchandise exports) of 1965 in Paraguay to that in Portugal?
Ensure brevity in your answer.  3.41. What is the ratio of the Exports(as % of merchandise exports) of 1962 in Paraguay to that in Singapore?
Ensure brevity in your answer.  0.98. What is the ratio of the Exports(as % of merchandise exports) of 1963 in Paraguay to that in Singapore?
Offer a terse response. 0.85. What is the ratio of the Exports(as % of merchandise exports) of 1964 in Paraguay to that in Singapore?
Make the answer very short. 0.99. What is the ratio of the Exports(as % of merchandise exports) in 1965 in Paraguay to that in Singapore?
Offer a very short reply. 1.12. What is the ratio of the Exports(as % of merchandise exports) in 1962 in Philippines to that in Portugal?
Your response must be concise. 2.44. What is the ratio of the Exports(as % of merchandise exports) of 1963 in Philippines to that in Portugal?
Provide a short and direct response. 2.58. What is the ratio of the Exports(as % of merchandise exports) of 1964 in Philippines to that in Portugal?
Offer a very short reply. 2.64. What is the ratio of the Exports(as % of merchandise exports) of 1965 in Philippines to that in Portugal?
Provide a short and direct response. 2.88. What is the ratio of the Exports(as % of merchandise exports) of 1962 in Philippines to that in Singapore?
Your answer should be compact. 0.74. What is the ratio of the Exports(as % of merchandise exports) of 1963 in Philippines to that in Singapore?
Offer a very short reply. 0.85. What is the ratio of the Exports(as % of merchandise exports) in 1964 in Philippines to that in Singapore?
Ensure brevity in your answer.  0.88. What is the ratio of the Exports(as % of merchandise exports) in 1965 in Philippines to that in Singapore?
Your answer should be compact. 0.94. What is the ratio of the Exports(as % of merchandise exports) of 1962 in Portugal to that in Singapore?
Give a very brief answer. 0.3. What is the ratio of the Exports(as % of merchandise exports) in 1963 in Portugal to that in Singapore?
Offer a terse response. 0.33. What is the ratio of the Exports(as % of merchandise exports) in 1964 in Portugal to that in Singapore?
Offer a terse response. 0.34. What is the ratio of the Exports(as % of merchandise exports) of 1965 in Portugal to that in Singapore?
Provide a succinct answer. 0.33. What is the difference between the highest and the second highest Exports(as % of merchandise exports) of 1962?
Make the answer very short. 0.76. What is the difference between the highest and the second highest Exports(as % of merchandise exports) of 1963?
Offer a terse response. 4.56. What is the difference between the highest and the second highest Exports(as % of merchandise exports) of 1964?
Give a very brief answer. 0.3. What is the difference between the highest and the second highest Exports(as % of merchandise exports) of 1965?
Make the answer very short. 3.07. What is the difference between the highest and the lowest Exports(as % of merchandise exports) of 1962?
Ensure brevity in your answer.  33.45. What is the difference between the highest and the lowest Exports(as % of merchandise exports) in 1963?
Your answer should be compact. 30.02. What is the difference between the highest and the lowest Exports(as % of merchandise exports) of 1964?
Provide a succinct answer. 26.35. What is the difference between the highest and the lowest Exports(as % of merchandise exports) of 1965?
Ensure brevity in your answer.  28.61. 